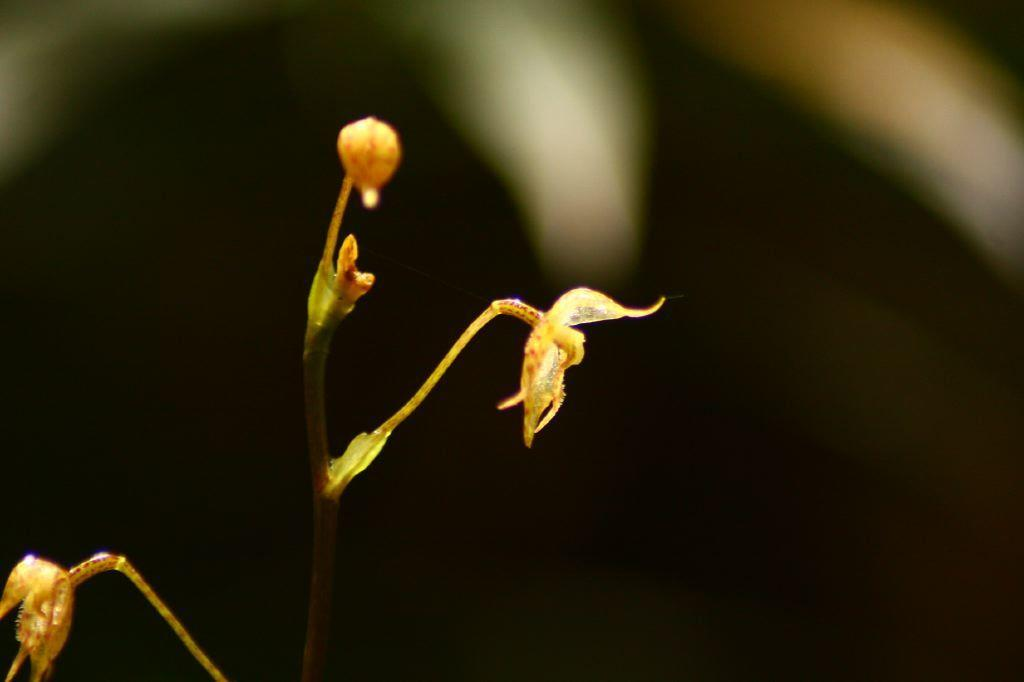What is present in the image? There is a plant in the image. What specific feature does the plant have? The plant has a flower. What color is the background of the image? The background of the image is black. How many horses are visible in the image? There are no horses present in the image; it features a plant with a flower against a black background. What type of book is being used as a prop in the image? There is no book present in the image. 